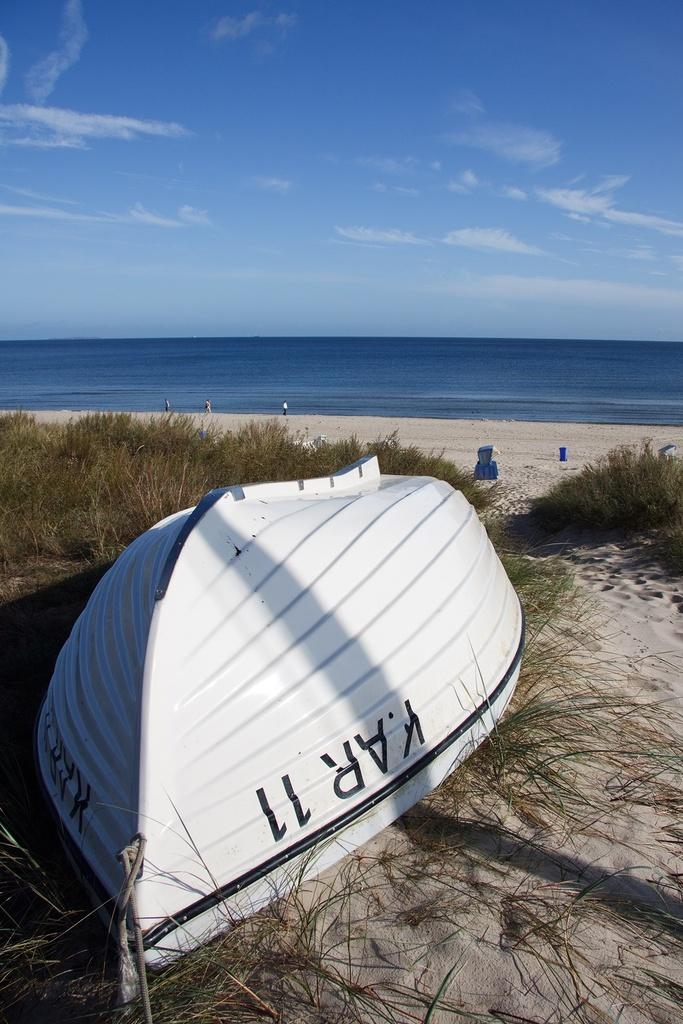What type of boat is in the image? There is a white color boat in the image. Where is the boat located? The boat is on the beach. What can be seen on the ground near the boat? There are plants on the ground. What is visible in the background of the image? There is an ocean and the sky in the background of the image. What is the condition of the sky in the image? The sky is visible with clouds in the background of the image. What type of popcorn is being served on the boat in the image? There is no popcorn present in the image; it features a white color boat on the beach. Can you tell me how many tails are visible on the boat in the image? Boats do not have tails, so this question cannot be answered based on the image. 